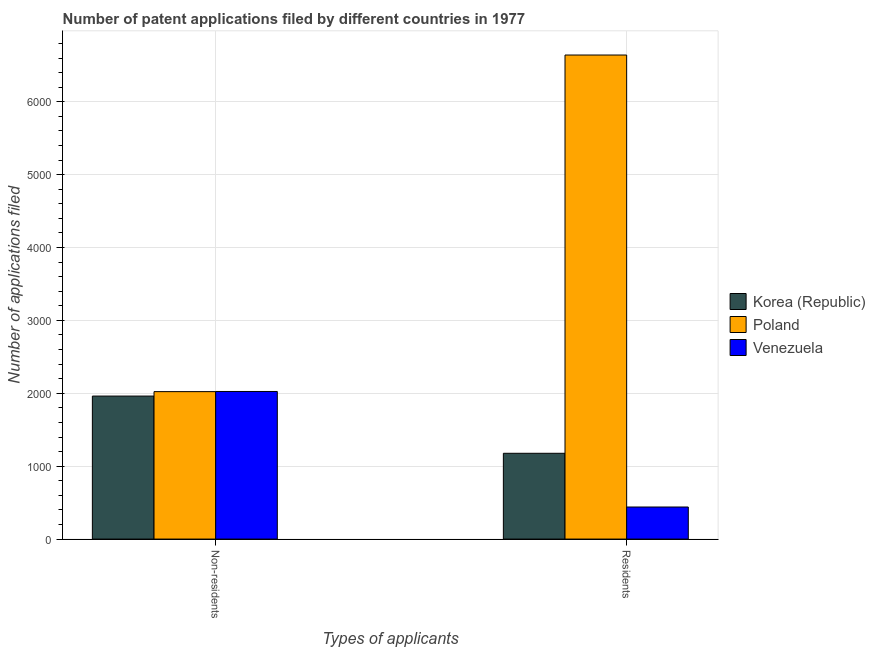Are the number of bars per tick equal to the number of legend labels?
Offer a terse response. Yes. Are the number of bars on each tick of the X-axis equal?
Keep it short and to the point. Yes. How many bars are there on the 1st tick from the left?
Your response must be concise. 3. How many bars are there on the 2nd tick from the right?
Your answer should be compact. 3. What is the label of the 2nd group of bars from the left?
Provide a short and direct response. Residents. What is the number of patent applications by residents in Venezuela?
Your answer should be compact. 440. Across all countries, what is the maximum number of patent applications by residents?
Ensure brevity in your answer.  6641. Across all countries, what is the minimum number of patent applications by non residents?
Offer a terse response. 1962. In which country was the number of patent applications by residents maximum?
Provide a short and direct response. Poland. In which country was the number of patent applications by residents minimum?
Provide a short and direct response. Venezuela. What is the total number of patent applications by non residents in the graph?
Provide a short and direct response. 6010. What is the difference between the number of patent applications by non residents in Korea (Republic) and that in Poland?
Your response must be concise. -61. What is the difference between the number of patent applications by non residents in Venezuela and the number of patent applications by residents in Korea (Republic)?
Your answer should be very brief. 848. What is the average number of patent applications by residents per country?
Your answer should be very brief. 2752.67. What is the difference between the number of patent applications by non residents and number of patent applications by residents in Korea (Republic)?
Your response must be concise. 785. What is the ratio of the number of patent applications by non residents in Poland to that in Venezuela?
Give a very brief answer. 1. What does the 1st bar from the left in Non-residents represents?
Make the answer very short. Korea (Republic). How many bars are there?
Offer a very short reply. 6. What is the difference between two consecutive major ticks on the Y-axis?
Offer a terse response. 1000. Does the graph contain any zero values?
Your answer should be very brief. No. Where does the legend appear in the graph?
Provide a succinct answer. Center right. What is the title of the graph?
Ensure brevity in your answer.  Number of patent applications filed by different countries in 1977. Does "Libya" appear as one of the legend labels in the graph?
Ensure brevity in your answer.  No. What is the label or title of the X-axis?
Provide a succinct answer. Types of applicants. What is the label or title of the Y-axis?
Offer a terse response. Number of applications filed. What is the Number of applications filed in Korea (Republic) in Non-residents?
Provide a succinct answer. 1962. What is the Number of applications filed in Poland in Non-residents?
Provide a short and direct response. 2023. What is the Number of applications filed in Venezuela in Non-residents?
Your response must be concise. 2025. What is the Number of applications filed in Korea (Republic) in Residents?
Provide a succinct answer. 1177. What is the Number of applications filed in Poland in Residents?
Ensure brevity in your answer.  6641. What is the Number of applications filed of Venezuela in Residents?
Your response must be concise. 440. Across all Types of applicants, what is the maximum Number of applications filed in Korea (Republic)?
Give a very brief answer. 1962. Across all Types of applicants, what is the maximum Number of applications filed in Poland?
Your answer should be very brief. 6641. Across all Types of applicants, what is the maximum Number of applications filed in Venezuela?
Keep it short and to the point. 2025. Across all Types of applicants, what is the minimum Number of applications filed of Korea (Republic)?
Offer a terse response. 1177. Across all Types of applicants, what is the minimum Number of applications filed in Poland?
Provide a succinct answer. 2023. Across all Types of applicants, what is the minimum Number of applications filed of Venezuela?
Offer a terse response. 440. What is the total Number of applications filed of Korea (Republic) in the graph?
Your response must be concise. 3139. What is the total Number of applications filed in Poland in the graph?
Give a very brief answer. 8664. What is the total Number of applications filed of Venezuela in the graph?
Your response must be concise. 2465. What is the difference between the Number of applications filed in Korea (Republic) in Non-residents and that in Residents?
Make the answer very short. 785. What is the difference between the Number of applications filed of Poland in Non-residents and that in Residents?
Offer a terse response. -4618. What is the difference between the Number of applications filed of Venezuela in Non-residents and that in Residents?
Offer a terse response. 1585. What is the difference between the Number of applications filed in Korea (Republic) in Non-residents and the Number of applications filed in Poland in Residents?
Provide a short and direct response. -4679. What is the difference between the Number of applications filed of Korea (Republic) in Non-residents and the Number of applications filed of Venezuela in Residents?
Ensure brevity in your answer.  1522. What is the difference between the Number of applications filed of Poland in Non-residents and the Number of applications filed of Venezuela in Residents?
Make the answer very short. 1583. What is the average Number of applications filed of Korea (Republic) per Types of applicants?
Offer a very short reply. 1569.5. What is the average Number of applications filed in Poland per Types of applicants?
Your answer should be compact. 4332. What is the average Number of applications filed in Venezuela per Types of applicants?
Provide a short and direct response. 1232.5. What is the difference between the Number of applications filed of Korea (Republic) and Number of applications filed of Poland in Non-residents?
Your answer should be compact. -61. What is the difference between the Number of applications filed of Korea (Republic) and Number of applications filed of Venezuela in Non-residents?
Your answer should be compact. -63. What is the difference between the Number of applications filed in Poland and Number of applications filed in Venezuela in Non-residents?
Provide a succinct answer. -2. What is the difference between the Number of applications filed of Korea (Republic) and Number of applications filed of Poland in Residents?
Give a very brief answer. -5464. What is the difference between the Number of applications filed in Korea (Republic) and Number of applications filed in Venezuela in Residents?
Give a very brief answer. 737. What is the difference between the Number of applications filed in Poland and Number of applications filed in Venezuela in Residents?
Keep it short and to the point. 6201. What is the ratio of the Number of applications filed of Korea (Republic) in Non-residents to that in Residents?
Your response must be concise. 1.67. What is the ratio of the Number of applications filed of Poland in Non-residents to that in Residents?
Ensure brevity in your answer.  0.3. What is the ratio of the Number of applications filed in Venezuela in Non-residents to that in Residents?
Your answer should be very brief. 4.6. What is the difference between the highest and the second highest Number of applications filed in Korea (Republic)?
Offer a very short reply. 785. What is the difference between the highest and the second highest Number of applications filed in Poland?
Offer a terse response. 4618. What is the difference between the highest and the second highest Number of applications filed in Venezuela?
Offer a very short reply. 1585. What is the difference between the highest and the lowest Number of applications filed of Korea (Republic)?
Your answer should be compact. 785. What is the difference between the highest and the lowest Number of applications filed in Poland?
Provide a succinct answer. 4618. What is the difference between the highest and the lowest Number of applications filed in Venezuela?
Your response must be concise. 1585. 